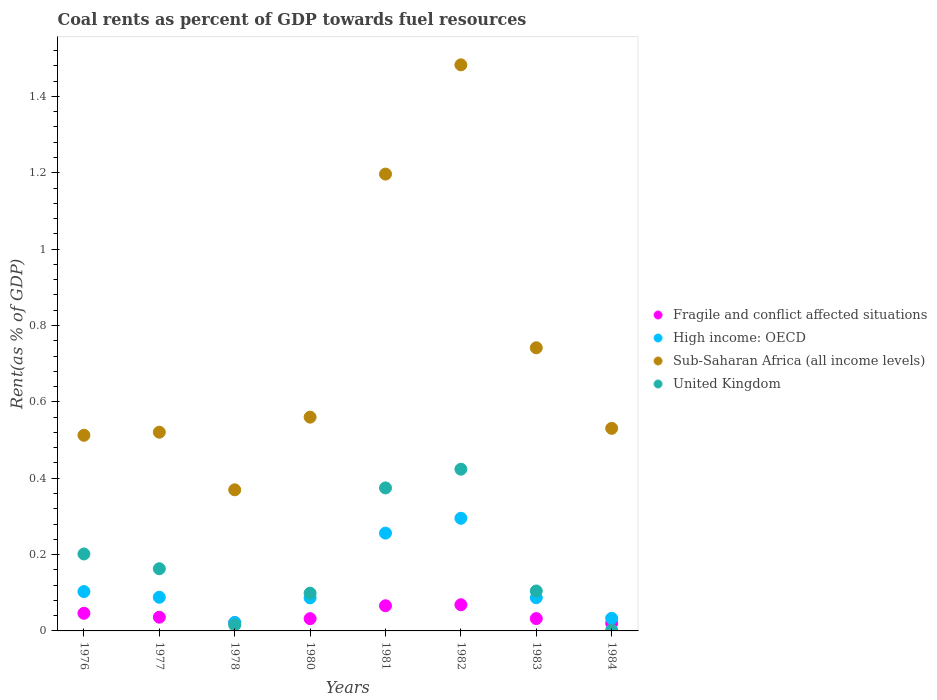How many different coloured dotlines are there?
Provide a succinct answer. 4. Is the number of dotlines equal to the number of legend labels?
Offer a very short reply. Yes. What is the coal rent in United Kingdom in 1976?
Make the answer very short. 0.2. Across all years, what is the maximum coal rent in High income: OECD?
Ensure brevity in your answer.  0.3. Across all years, what is the minimum coal rent in High income: OECD?
Give a very brief answer. 0.02. In which year was the coal rent in High income: OECD minimum?
Ensure brevity in your answer.  1978. What is the total coal rent in High income: OECD in the graph?
Make the answer very short. 0.97. What is the difference between the coal rent in United Kingdom in 1980 and that in 1981?
Keep it short and to the point. -0.28. What is the difference between the coal rent in United Kingdom in 1981 and the coal rent in High income: OECD in 1980?
Keep it short and to the point. 0.29. What is the average coal rent in High income: OECD per year?
Offer a terse response. 0.12. In the year 1981, what is the difference between the coal rent in High income: OECD and coal rent in United Kingdom?
Keep it short and to the point. -0.12. In how many years, is the coal rent in Fragile and conflict affected situations greater than 1.4800000000000002 %?
Give a very brief answer. 0. What is the ratio of the coal rent in Fragile and conflict affected situations in 1978 to that in 1984?
Your response must be concise. 1.08. Is the difference between the coal rent in High income: OECD in 1976 and 1982 greater than the difference between the coal rent in United Kingdom in 1976 and 1982?
Your answer should be very brief. Yes. What is the difference between the highest and the second highest coal rent in Fragile and conflict affected situations?
Offer a very short reply. 0. What is the difference between the highest and the lowest coal rent in United Kingdom?
Ensure brevity in your answer.  0.42. Is the coal rent in Sub-Saharan Africa (all income levels) strictly greater than the coal rent in United Kingdom over the years?
Provide a short and direct response. Yes. How many dotlines are there?
Offer a very short reply. 4. What is the difference between two consecutive major ticks on the Y-axis?
Provide a succinct answer. 0.2. Are the values on the major ticks of Y-axis written in scientific E-notation?
Your answer should be compact. No. Does the graph contain any zero values?
Offer a very short reply. No. How many legend labels are there?
Your answer should be compact. 4. How are the legend labels stacked?
Your response must be concise. Vertical. What is the title of the graph?
Offer a terse response. Coal rents as percent of GDP towards fuel resources. What is the label or title of the X-axis?
Give a very brief answer. Years. What is the label or title of the Y-axis?
Give a very brief answer. Rent(as % of GDP). What is the Rent(as % of GDP) of Fragile and conflict affected situations in 1976?
Your response must be concise. 0.05. What is the Rent(as % of GDP) of High income: OECD in 1976?
Keep it short and to the point. 0.1. What is the Rent(as % of GDP) in Sub-Saharan Africa (all income levels) in 1976?
Provide a short and direct response. 0.51. What is the Rent(as % of GDP) in United Kingdom in 1976?
Keep it short and to the point. 0.2. What is the Rent(as % of GDP) of Fragile and conflict affected situations in 1977?
Offer a terse response. 0.04. What is the Rent(as % of GDP) of High income: OECD in 1977?
Provide a succinct answer. 0.09. What is the Rent(as % of GDP) of Sub-Saharan Africa (all income levels) in 1977?
Your response must be concise. 0.52. What is the Rent(as % of GDP) of United Kingdom in 1977?
Offer a very short reply. 0.16. What is the Rent(as % of GDP) in Fragile and conflict affected situations in 1978?
Provide a short and direct response. 0.02. What is the Rent(as % of GDP) of High income: OECD in 1978?
Offer a terse response. 0.02. What is the Rent(as % of GDP) in Sub-Saharan Africa (all income levels) in 1978?
Your response must be concise. 0.37. What is the Rent(as % of GDP) in United Kingdom in 1978?
Your answer should be compact. 0.02. What is the Rent(as % of GDP) of Fragile and conflict affected situations in 1980?
Offer a very short reply. 0.03. What is the Rent(as % of GDP) in High income: OECD in 1980?
Provide a short and direct response. 0.09. What is the Rent(as % of GDP) in Sub-Saharan Africa (all income levels) in 1980?
Your response must be concise. 0.56. What is the Rent(as % of GDP) of United Kingdom in 1980?
Provide a short and direct response. 0.1. What is the Rent(as % of GDP) of Fragile and conflict affected situations in 1981?
Your response must be concise. 0.07. What is the Rent(as % of GDP) of High income: OECD in 1981?
Make the answer very short. 0.26. What is the Rent(as % of GDP) of Sub-Saharan Africa (all income levels) in 1981?
Make the answer very short. 1.2. What is the Rent(as % of GDP) in United Kingdom in 1981?
Offer a terse response. 0.37. What is the Rent(as % of GDP) in Fragile and conflict affected situations in 1982?
Offer a terse response. 0.07. What is the Rent(as % of GDP) of High income: OECD in 1982?
Give a very brief answer. 0.3. What is the Rent(as % of GDP) of Sub-Saharan Africa (all income levels) in 1982?
Provide a short and direct response. 1.48. What is the Rent(as % of GDP) of United Kingdom in 1982?
Keep it short and to the point. 0.42. What is the Rent(as % of GDP) in Fragile and conflict affected situations in 1983?
Give a very brief answer. 0.03. What is the Rent(as % of GDP) of High income: OECD in 1983?
Your answer should be compact. 0.09. What is the Rent(as % of GDP) of Sub-Saharan Africa (all income levels) in 1983?
Your answer should be compact. 0.74. What is the Rent(as % of GDP) in United Kingdom in 1983?
Your answer should be very brief. 0.1. What is the Rent(as % of GDP) of Fragile and conflict affected situations in 1984?
Your answer should be very brief. 0.02. What is the Rent(as % of GDP) in High income: OECD in 1984?
Your answer should be very brief. 0.03. What is the Rent(as % of GDP) of Sub-Saharan Africa (all income levels) in 1984?
Offer a very short reply. 0.53. What is the Rent(as % of GDP) of United Kingdom in 1984?
Your response must be concise. 0. Across all years, what is the maximum Rent(as % of GDP) of Fragile and conflict affected situations?
Your answer should be compact. 0.07. Across all years, what is the maximum Rent(as % of GDP) of High income: OECD?
Make the answer very short. 0.3. Across all years, what is the maximum Rent(as % of GDP) of Sub-Saharan Africa (all income levels)?
Your response must be concise. 1.48. Across all years, what is the maximum Rent(as % of GDP) in United Kingdom?
Provide a short and direct response. 0.42. Across all years, what is the minimum Rent(as % of GDP) in Fragile and conflict affected situations?
Offer a terse response. 0.02. Across all years, what is the minimum Rent(as % of GDP) in High income: OECD?
Keep it short and to the point. 0.02. Across all years, what is the minimum Rent(as % of GDP) in Sub-Saharan Africa (all income levels)?
Offer a terse response. 0.37. Across all years, what is the minimum Rent(as % of GDP) of United Kingdom?
Your response must be concise. 0. What is the total Rent(as % of GDP) in Fragile and conflict affected situations in the graph?
Ensure brevity in your answer.  0.32. What is the total Rent(as % of GDP) of High income: OECD in the graph?
Provide a succinct answer. 0.97. What is the total Rent(as % of GDP) of Sub-Saharan Africa (all income levels) in the graph?
Your answer should be compact. 5.91. What is the total Rent(as % of GDP) of United Kingdom in the graph?
Your answer should be compact. 1.38. What is the difference between the Rent(as % of GDP) in Fragile and conflict affected situations in 1976 and that in 1977?
Keep it short and to the point. 0.01. What is the difference between the Rent(as % of GDP) in High income: OECD in 1976 and that in 1977?
Keep it short and to the point. 0.01. What is the difference between the Rent(as % of GDP) of Sub-Saharan Africa (all income levels) in 1976 and that in 1977?
Provide a succinct answer. -0.01. What is the difference between the Rent(as % of GDP) in United Kingdom in 1976 and that in 1977?
Provide a succinct answer. 0.04. What is the difference between the Rent(as % of GDP) in Fragile and conflict affected situations in 1976 and that in 1978?
Your answer should be compact. 0.02. What is the difference between the Rent(as % of GDP) in High income: OECD in 1976 and that in 1978?
Your answer should be compact. 0.08. What is the difference between the Rent(as % of GDP) in Sub-Saharan Africa (all income levels) in 1976 and that in 1978?
Your response must be concise. 0.14. What is the difference between the Rent(as % of GDP) of United Kingdom in 1976 and that in 1978?
Ensure brevity in your answer.  0.19. What is the difference between the Rent(as % of GDP) in Fragile and conflict affected situations in 1976 and that in 1980?
Your answer should be compact. 0.01. What is the difference between the Rent(as % of GDP) in High income: OECD in 1976 and that in 1980?
Your answer should be compact. 0.02. What is the difference between the Rent(as % of GDP) of Sub-Saharan Africa (all income levels) in 1976 and that in 1980?
Provide a short and direct response. -0.05. What is the difference between the Rent(as % of GDP) in United Kingdom in 1976 and that in 1980?
Your answer should be very brief. 0.1. What is the difference between the Rent(as % of GDP) in Fragile and conflict affected situations in 1976 and that in 1981?
Give a very brief answer. -0.02. What is the difference between the Rent(as % of GDP) of High income: OECD in 1976 and that in 1981?
Provide a short and direct response. -0.15. What is the difference between the Rent(as % of GDP) of Sub-Saharan Africa (all income levels) in 1976 and that in 1981?
Provide a short and direct response. -0.68. What is the difference between the Rent(as % of GDP) of United Kingdom in 1976 and that in 1981?
Keep it short and to the point. -0.17. What is the difference between the Rent(as % of GDP) in Fragile and conflict affected situations in 1976 and that in 1982?
Your answer should be compact. -0.02. What is the difference between the Rent(as % of GDP) in High income: OECD in 1976 and that in 1982?
Offer a terse response. -0.19. What is the difference between the Rent(as % of GDP) of Sub-Saharan Africa (all income levels) in 1976 and that in 1982?
Keep it short and to the point. -0.97. What is the difference between the Rent(as % of GDP) in United Kingdom in 1976 and that in 1982?
Ensure brevity in your answer.  -0.22. What is the difference between the Rent(as % of GDP) of Fragile and conflict affected situations in 1976 and that in 1983?
Offer a very short reply. 0.01. What is the difference between the Rent(as % of GDP) in High income: OECD in 1976 and that in 1983?
Your response must be concise. 0.02. What is the difference between the Rent(as % of GDP) of Sub-Saharan Africa (all income levels) in 1976 and that in 1983?
Offer a terse response. -0.23. What is the difference between the Rent(as % of GDP) of United Kingdom in 1976 and that in 1983?
Keep it short and to the point. 0.1. What is the difference between the Rent(as % of GDP) in Fragile and conflict affected situations in 1976 and that in 1984?
Provide a short and direct response. 0.03. What is the difference between the Rent(as % of GDP) in High income: OECD in 1976 and that in 1984?
Offer a terse response. 0.07. What is the difference between the Rent(as % of GDP) in Sub-Saharan Africa (all income levels) in 1976 and that in 1984?
Provide a succinct answer. -0.02. What is the difference between the Rent(as % of GDP) in United Kingdom in 1976 and that in 1984?
Your answer should be very brief. 0.2. What is the difference between the Rent(as % of GDP) in Fragile and conflict affected situations in 1977 and that in 1978?
Your answer should be compact. 0.01. What is the difference between the Rent(as % of GDP) in High income: OECD in 1977 and that in 1978?
Your answer should be compact. 0.07. What is the difference between the Rent(as % of GDP) of Sub-Saharan Africa (all income levels) in 1977 and that in 1978?
Keep it short and to the point. 0.15. What is the difference between the Rent(as % of GDP) in United Kingdom in 1977 and that in 1978?
Ensure brevity in your answer.  0.15. What is the difference between the Rent(as % of GDP) of Fragile and conflict affected situations in 1977 and that in 1980?
Provide a short and direct response. 0. What is the difference between the Rent(as % of GDP) of High income: OECD in 1977 and that in 1980?
Ensure brevity in your answer.  0. What is the difference between the Rent(as % of GDP) of Sub-Saharan Africa (all income levels) in 1977 and that in 1980?
Offer a very short reply. -0.04. What is the difference between the Rent(as % of GDP) in United Kingdom in 1977 and that in 1980?
Ensure brevity in your answer.  0.06. What is the difference between the Rent(as % of GDP) of Fragile and conflict affected situations in 1977 and that in 1981?
Your response must be concise. -0.03. What is the difference between the Rent(as % of GDP) of High income: OECD in 1977 and that in 1981?
Your response must be concise. -0.17. What is the difference between the Rent(as % of GDP) of Sub-Saharan Africa (all income levels) in 1977 and that in 1981?
Provide a succinct answer. -0.68. What is the difference between the Rent(as % of GDP) of United Kingdom in 1977 and that in 1981?
Keep it short and to the point. -0.21. What is the difference between the Rent(as % of GDP) in Fragile and conflict affected situations in 1977 and that in 1982?
Your answer should be compact. -0.03. What is the difference between the Rent(as % of GDP) in High income: OECD in 1977 and that in 1982?
Offer a very short reply. -0.21. What is the difference between the Rent(as % of GDP) in Sub-Saharan Africa (all income levels) in 1977 and that in 1982?
Make the answer very short. -0.96. What is the difference between the Rent(as % of GDP) of United Kingdom in 1977 and that in 1982?
Your answer should be compact. -0.26. What is the difference between the Rent(as % of GDP) of Fragile and conflict affected situations in 1977 and that in 1983?
Keep it short and to the point. 0. What is the difference between the Rent(as % of GDP) in High income: OECD in 1977 and that in 1983?
Ensure brevity in your answer.  0. What is the difference between the Rent(as % of GDP) in Sub-Saharan Africa (all income levels) in 1977 and that in 1983?
Ensure brevity in your answer.  -0.22. What is the difference between the Rent(as % of GDP) of United Kingdom in 1977 and that in 1983?
Your answer should be compact. 0.06. What is the difference between the Rent(as % of GDP) in Fragile and conflict affected situations in 1977 and that in 1984?
Offer a terse response. 0.02. What is the difference between the Rent(as % of GDP) in High income: OECD in 1977 and that in 1984?
Provide a short and direct response. 0.06. What is the difference between the Rent(as % of GDP) in Sub-Saharan Africa (all income levels) in 1977 and that in 1984?
Your answer should be compact. -0.01. What is the difference between the Rent(as % of GDP) in United Kingdom in 1977 and that in 1984?
Offer a very short reply. 0.16. What is the difference between the Rent(as % of GDP) of Fragile and conflict affected situations in 1978 and that in 1980?
Your answer should be compact. -0.01. What is the difference between the Rent(as % of GDP) in High income: OECD in 1978 and that in 1980?
Provide a succinct answer. -0.06. What is the difference between the Rent(as % of GDP) of Sub-Saharan Africa (all income levels) in 1978 and that in 1980?
Your response must be concise. -0.19. What is the difference between the Rent(as % of GDP) of United Kingdom in 1978 and that in 1980?
Ensure brevity in your answer.  -0.08. What is the difference between the Rent(as % of GDP) in Fragile and conflict affected situations in 1978 and that in 1981?
Your response must be concise. -0.04. What is the difference between the Rent(as % of GDP) in High income: OECD in 1978 and that in 1981?
Make the answer very short. -0.23. What is the difference between the Rent(as % of GDP) of Sub-Saharan Africa (all income levels) in 1978 and that in 1981?
Make the answer very short. -0.83. What is the difference between the Rent(as % of GDP) of United Kingdom in 1978 and that in 1981?
Give a very brief answer. -0.36. What is the difference between the Rent(as % of GDP) of Fragile and conflict affected situations in 1978 and that in 1982?
Provide a short and direct response. -0.05. What is the difference between the Rent(as % of GDP) in High income: OECD in 1978 and that in 1982?
Provide a short and direct response. -0.27. What is the difference between the Rent(as % of GDP) of Sub-Saharan Africa (all income levels) in 1978 and that in 1982?
Make the answer very short. -1.11. What is the difference between the Rent(as % of GDP) in United Kingdom in 1978 and that in 1982?
Give a very brief answer. -0.41. What is the difference between the Rent(as % of GDP) of Fragile and conflict affected situations in 1978 and that in 1983?
Keep it short and to the point. -0.01. What is the difference between the Rent(as % of GDP) in High income: OECD in 1978 and that in 1983?
Provide a short and direct response. -0.06. What is the difference between the Rent(as % of GDP) in Sub-Saharan Africa (all income levels) in 1978 and that in 1983?
Your answer should be compact. -0.37. What is the difference between the Rent(as % of GDP) in United Kingdom in 1978 and that in 1983?
Make the answer very short. -0.09. What is the difference between the Rent(as % of GDP) in Fragile and conflict affected situations in 1978 and that in 1984?
Ensure brevity in your answer.  0. What is the difference between the Rent(as % of GDP) in High income: OECD in 1978 and that in 1984?
Your answer should be compact. -0.01. What is the difference between the Rent(as % of GDP) in Sub-Saharan Africa (all income levels) in 1978 and that in 1984?
Provide a succinct answer. -0.16. What is the difference between the Rent(as % of GDP) in United Kingdom in 1978 and that in 1984?
Your response must be concise. 0.01. What is the difference between the Rent(as % of GDP) of Fragile and conflict affected situations in 1980 and that in 1981?
Make the answer very short. -0.03. What is the difference between the Rent(as % of GDP) of High income: OECD in 1980 and that in 1981?
Ensure brevity in your answer.  -0.17. What is the difference between the Rent(as % of GDP) in Sub-Saharan Africa (all income levels) in 1980 and that in 1981?
Offer a very short reply. -0.64. What is the difference between the Rent(as % of GDP) in United Kingdom in 1980 and that in 1981?
Make the answer very short. -0.28. What is the difference between the Rent(as % of GDP) in Fragile and conflict affected situations in 1980 and that in 1982?
Give a very brief answer. -0.04. What is the difference between the Rent(as % of GDP) of High income: OECD in 1980 and that in 1982?
Make the answer very short. -0.21. What is the difference between the Rent(as % of GDP) of Sub-Saharan Africa (all income levels) in 1980 and that in 1982?
Your answer should be compact. -0.92. What is the difference between the Rent(as % of GDP) in United Kingdom in 1980 and that in 1982?
Ensure brevity in your answer.  -0.32. What is the difference between the Rent(as % of GDP) in Fragile and conflict affected situations in 1980 and that in 1983?
Offer a very short reply. -0. What is the difference between the Rent(as % of GDP) in High income: OECD in 1980 and that in 1983?
Your response must be concise. -0. What is the difference between the Rent(as % of GDP) in Sub-Saharan Africa (all income levels) in 1980 and that in 1983?
Keep it short and to the point. -0.18. What is the difference between the Rent(as % of GDP) of United Kingdom in 1980 and that in 1983?
Keep it short and to the point. -0.01. What is the difference between the Rent(as % of GDP) in Fragile and conflict affected situations in 1980 and that in 1984?
Keep it short and to the point. 0.01. What is the difference between the Rent(as % of GDP) of High income: OECD in 1980 and that in 1984?
Offer a very short reply. 0.05. What is the difference between the Rent(as % of GDP) in Sub-Saharan Africa (all income levels) in 1980 and that in 1984?
Ensure brevity in your answer.  0.03. What is the difference between the Rent(as % of GDP) of United Kingdom in 1980 and that in 1984?
Your answer should be very brief. 0.1. What is the difference between the Rent(as % of GDP) in Fragile and conflict affected situations in 1981 and that in 1982?
Your answer should be very brief. -0. What is the difference between the Rent(as % of GDP) in High income: OECD in 1981 and that in 1982?
Your answer should be compact. -0.04. What is the difference between the Rent(as % of GDP) in Sub-Saharan Africa (all income levels) in 1981 and that in 1982?
Keep it short and to the point. -0.29. What is the difference between the Rent(as % of GDP) of United Kingdom in 1981 and that in 1982?
Your answer should be very brief. -0.05. What is the difference between the Rent(as % of GDP) of Fragile and conflict affected situations in 1981 and that in 1983?
Your response must be concise. 0.03. What is the difference between the Rent(as % of GDP) of High income: OECD in 1981 and that in 1983?
Your response must be concise. 0.17. What is the difference between the Rent(as % of GDP) of Sub-Saharan Africa (all income levels) in 1981 and that in 1983?
Provide a succinct answer. 0.45. What is the difference between the Rent(as % of GDP) of United Kingdom in 1981 and that in 1983?
Make the answer very short. 0.27. What is the difference between the Rent(as % of GDP) of Fragile and conflict affected situations in 1981 and that in 1984?
Make the answer very short. 0.05. What is the difference between the Rent(as % of GDP) of High income: OECD in 1981 and that in 1984?
Your answer should be compact. 0.22. What is the difference between the Rent(as % of GDP) of Sub-Saharan Africa (all income levels) in 1981 and that in 1984?
Your answer should be very brief. 0.67. What is the difference between the Rent(as % of GDP) in United Kingdom in 1981 and that in 1984?
Ensure brevity in your answer.  0.37. What is the difference between the Rent(as % of GDP) in Fragile and conflict affected situations in 1982 and that in 1983?
Give a very brief answer. 0.04. What is the difference between the Rent(as % of GDP) of High income: OECD in 1982 and that in 1983?
Offer a very short reply. 0.21. What is the difference between the Rent(as % of GDP) of Sub-Saharan Africa (all income levels) in 1982 and that in 1983?
Offer a terse response. 0.74. What is the difference between the Rent(as % of GDP) in United Kingdom in 1982 and that in 1983?
Provide a succinct answer. 0.32. What is the difference between the Rent(as % of GDP) of Fragile and conflict affected situations in 1982 and that in 1984?
Ensure brevity in your answer.  0.05. What is the difference between the Rent(as % of GDP) of High income: OECD in 1982 and that in 1984?
Make the answer very short. 0.26. What is the difference between the Rent(as % of GDP) of Sub-Saharan Africa (all income levels) in 1982 and that in 1984?
Ensure brevity in your answer.  0.95. What is the difference between the Rent(as % of GDP) in United Kingdom in 1982 and that in 1984?
Provide a short and direct response. 0.42. What is the difference between the Rent(as % of GDP) of Fragile and conflict affected situations in 1983 and that in 1984?
Provide a short and direct response. 0.01. What is the difference between the Rent(as % of GDP) of High income: OECD in 1983 and that in 1984?
Your answer should be compact. 0.05. What is the difference between the Rent(as % of GDP) in Sub-Saharan Africa (all income levels) in 1983 and that in 1984?
Your answer should be compact. 0.21. What is the difference between the Rent(as % of GDP) of United Kingdom in 1983 and that in 1984?
Provide a succinct answer. 0.1. What is the difference between the Rent(as % of GDP) in Fragile and conflict affected situations in 1976 and the Rent(as % of GDP) in High income: OECD in 1977?
Your answer should be very brief. -0.04. What is the difference between the Rent(as % of GDP) of Fragile and conflict affected situations in 1976 and the Rent(as % of GDP) of Sub-Saharan Africa (all income levels) in 1977?
Provide a succinct answer. -0.47. What is the difference between the Rent(as % of GDP) in Fragile and conflict affected situations in 1976 and the Rent(as % of GDP) in United Kingdom in 1977?
Your response must be concise. -0.12. What is the difference between the Rent(as % of GDP) of High income: OECD in 1976 and the Rent(as % of GDP) of Sub-Saharan Africa (all income levels) in 1977?
Give a very brief answer. -0.42. What is the difference between the Rent(as % of GDP) in High income: OECD in 1976 and the Rent(as % of GDP) in United Kingdom in 1977?
Ensure brevity in your answer.  -0.06. What is the difference between the Rent(as % of GDP) in Sub-Saharan Africa (all income levels) in 1976 and the Rent(as % of GDP) in United Kingdom in 1977?
Give a very brief answer. 0.35. What is the difference between the Rent(as % of GDP) in Fragile and conflict affected situations in 1976 and the Rent(as % of GDP) in High income: OECD in 1978?
Keep it short and to the point. 0.02. What is the difference between the Rent(as % of GDP) in Fragile and conflict affected situations in 1976 and the Rent(as % of GDP) in Sub-Saharan Africa (all income levels) in 1978?
Your answer should be compact. -0.32. What is the difference between the Rent(as % of GDP) in Fragile and conflict affected situations in 1976 and the Rent(as % of GDP) in United Kingdom in 1978?
Offer a terse response. 0.03. What is the difference between the Rent(as % of GDP) in High income: OECD in 1976 and the Rent(as % of GDP) in Sub-Saharan Africa (all income levels) in 1978?
Your answer should be compact. -0.27. What is the difference between the Rent(as % of GDP) in High income: OECD in 1976 and the Rent(as % of GDP) in United Kingdom in 1978?
Your answer should be very brief. 0.09. What is the difference between the Rent(as % of GDP) in Sub-Saharan Africa (all income levels) in 1976 and the Rent(as % of GDP) in United Kingdom in 1978?
Give a very brief answer. 0.5. What is the difference between the Rent(as % of GDP) in Fragile and conflict affected situations in 1976 and the Rent(as % of GDP) in High income: OECD in 1980?
Provide a succinct answer. -0.04. What is the difference between the Rent(as % of GDP) of Fragile and conflict affected situations in 1976 and the Rent(as % of GDP) of Sub-Saharan Africa (all income levels) in 1980?
Offer a terse response. -0.51. What is the difference between the Rent(as % of GDP) in Fragile and conflict affected situations in 1976 and the Rent(as % of GDP) in United Kingdom in 1980?
Provide a succinct answer. -0.05. What is the difference between the Rent(as % of GDP) of High income: OECD in 1976 and the Rent(as % of GDP) of Sub-Saharan Africa (all income levels) in 1980?
Give a very brief answer. -0.46. What is the difference between the Rent(as % of GDP) of High income: OECD in 1976 and the Rent(as % of GDP) of United Kingdom in 1980?
Offer a terse response. 0. What is the difference between the Rent(as % of GDP) in Sub-Saharan Africa (all income levels) in 1976 and the Rent(as % of GDP) in United Kingdom in 1980?
Make the answer very short. 0.41. What is the difference between the Rent(as % of GDP) in Fragile and conflict affected situations in 1976 and the Rent(as % of GDP) in High income: OECD in 1981?
Your answer should be compact. -0.21. What is the difference between the Rent(as % of GDP) in Fragile and conflict affected situations in 1976 and the Rent(as % of GDP) in Sub-Saharan Africa (all income levels) in 1981?
Keep it short and to the point. -1.15. What is the difference between the Rent(as % of GDP) of Fragile and conflict affected situations in 1976 and the Rent(as % of GDP) of United Kingdom in 1981?
Offer a very short reply. -0.33. What is the difference between the Rent(as % of GDP) in High income: OECD in 1976 and the Rent(as % of GDP) in Sub-Saharan Africa (all income levels) in 1981?
Your answer should be very brief. -1.09. What is the difference between the Rent(as % of GDP) of High income: OECD in 1976 and the Rent(as % of GDP) of United Kingdom in 1981?
Offer a very short reply. -0.27. What is the difference between the Rent(as % of GDP) in Sub-Saharan Africa (all income levels) in 1976 and the Rent(as % of GDP) in United Kingdom in 1981?
Ensure brevity in your answer.  0.14. What is the difference between the Rent(as % of GDP) of Fragile and conflict affected situations in 1976 and the Rent(as % of GDP) of High income: OECD in 1982?
Your answer should be very brief. -0.25. What is the difference between the Rent(as % of GDP) in Fragile and conflict affected situations in 1976 and the Rent(as % of GDP) in Sub-Saharan Africa (all income levels) in 1982?
Offer a very short reply. -1.44. What is the difference between the Rent(as % of GDP) in Fragile and conflict affected situations in 1976 and the Rent(as % of GDP) in United Kingdom in 1982?
Keep it short and to the point. -0.38. What is the difference between the Rent(as % of GDP) in High income: OECD in 1976 and the Rent(as % of GDP) in Sub-Saharan Africa (all income levels) in 1982?
Offer a very short reply. -1.38. What is the difference between the Rent(as % of GDP) in High income: OECD in 1976 and the Rent(as % of GDP) in United Kingdom in 1982?
Provide a short and direct response. -0.32. What is the difference between the Rent(as % of GDP) of Sub-Saharan Africa (all income levels) in 1976 and the Rent(as % of GDP) of United Kingdom in 1982?
Offer a terse response. 0.09. What is the difference between the Rent(as % of GDP) in Fragile and conflict affected situations in 1976 and the Rent(as % of GDP) in High income: OECD in 1983?
Your response must be concise. -0.04. What is the difference between the Rent(as % of GDP) of Fragile and conflict affected situations in 1976 and the Rent(as % of GDP) of Sub-Saharan Africa (all income levels) in 1983?
Make the answer very short. -0.7. What is the difference between the Rent(as % of GDP) in Fragile and conflict affected situations in 1976 and the Rent(as % of GDP) in United Kingdom in 1983?
Keep it short and to the point. -0.06. What is the difference between the Rent(as % of GDP) of High income: OECD in 1976 and the Rent(as % of GDP) of Sub-Saharan Africa (all income levels) in 1983?
Offer a terse response. -0.64. What is the difference between the Rent(as % of GDP) of High income: OECD in 1976 and the Rent(as % of GDP) of United Kingdom in 1983?
Your answer should be very brief. -0. What is the difference between the Rent(as % of GDP) of Sub-Saharan Africa (all income levels) in 1976 and the Rent(as % of GDP) of United Kingdom in 1983?
Make the answer very short. 0.41. What is the difference between the Rent(as % of GDP) in Fragile and conflict affected situations in 1976 and the Rent(as % of GDP) in High income: OECD in 1984?
Make the answer very short. 0.01. What is the difference between the Rent(as % of GDP) in Fragile and conflict affected situations in 1976 and the Rent(as % of GDP) in Sub-Saharan Africa (all income levels) in 1984?
Your response must be concise. -0.48. What is the difference between the Rent(as % of GDP) in Fragile and conflict affected situations in 1976 and the Rent(as % of GDP) in United Kingdom in 1984?
Ensure brevity in your answer.  0.04. What is the difference between the Rent(as % of GDP) of High income: OECD in 1976 and the Rent(as % of GDP) of Sub-Saharan Africa (all income levels) in 1984?
Your answer should be very brief. -0.43. What is the difference between the Rent(as % of GDP) of High income: OECD in 1976 and the Rent(as % of GDP) of United Kingdom in 1984?
Your answer should be very brief. 0.1. What is the difference between the Rent(as % of GDP) in Sub-Saharan Africa (all income levels) in 1976 and the Rent(as % of GDP) in United Kingdom in 1984?
Your answer should be compact. 0.51. What is the difference between the Rent(as % of GDP) of Fragile and conflict affected situations in 1977 and the Rent(as % of GDP) of High income: OECD in 1978?
Your response must be concise. 0.01. What is the difference between the Rent(as % of GDP) in Fragile and conflict affected situations in 1977 and the Rent(as % of GDP) in Sub-Saharan Africa (all income levels) in 1978?
Make the answer very short. -0.33. What is the difference between the Rent(as % of GDP) in Fragile and conflict affected situations in 1977 and the Rent(as % of GDP) in United Kingdom in 1978?
Your answer should be very brief. 0.02. What is the difference between the Rent(as % of GDP) in High income: OECD in 1977 and the Rent(as % of GDP) in Sub-Saharan Africa (all income levels) in 1978?
Keep it short and to the point. -0.28. What is the difference between the Rent(as % of GDP) in High income: OECD in 1977 and the Rent(as % of GDP) in United Kingdom in 1978?
Provide a short and direct response. 0.07. What is the difference between the Rent(as % of GDP) of Sub-Saharan Africa (all income levels) in 1977 and the Rent(as % of GDP) of United Kingdom in 1978?
Provide a succinct answer. 0.51. What is the difference between the Rent(as % of GDP) of Fragile and conflict affected situations in 1977 and the Rent(as % of GDP) of High income: OECD in 1980?
Keep it short and to the point. -0.05. What is the difference between the Rent(as % of GDP) in Fragile and conflict affected situations in 1977 and the Rent(as % of GDP) in Sub-Saharan Africa (all income levels) in 1980?
Provide a succinct answer. -0.52. What is the difference between the Rent(as % of GDP) of Fragile and conflict affected situations in 1977 and the Rent(as % of GDP) of United Kingdom in 1980?
Keep it short and to the point. -0.06. What is the difference between the Rent(as % of GDP) in High income: OECD in 1977 and the Rent(as % of GDP) in Sub-Saharan Africa (all income levels) in 1980?
Give a very brief answer. -0.47. What is the difference between the Rent(as % of GDP) of High income: OECD in 1977 and the Rent(as % of GDP) of United Kingdom in 1980?
Provide a short and direct response. -0.01. What is the difference between the Rent(as % of GDP) in Sub-Saharan Africa (all income levels) in 1977 and the Rent(as % of GDP) in United Kingdom in 1980?
Make the answer very short. 0.42. What is the difference between the Rent(as % of GDP) in Fragile and conflict affected situations in 1977 and the Rent(as % of GDP) in High income: OECD in 1981?
Offer a very short reply. -0.22. What is the difference between the Rent(as % of GDP) in Fragile and conflict affected situations in 1977 and the Rent(as % of GDP) in Sub-Saharan Africa (all income levels) in 1981?
Offer a terse response. -1.16. What is the difference between the Rent(as % of GDP) of Fragile and conflict affected situations in 1977 and the Rent(as % of GDP) of United Kingdom in 1981?
Your response must be concise. -0.34. What is the difference between the Rent(as % of GDP) of High income: OECD in 1977 and the Rent(as % of GDP) of Sub-Saharan Africa (all income levels) in 1981?
Your answer should be very brief. -1.11. What is the difference between the Rent(as % of GDP) in High income: OECD in 1977 and the Rent(as % of GDP) in United Kingdom in 1981?
Offer a very short reply. -0.29. What is the difference between the Rent(as % of GDP) in Sub-Saharan Africa (all income levels) in 1977 and the Rent(as % of GDP) in United Kingdom in 1981?
Make the answer very short. 0.15. What is the difference between the Rent(as % of GDP) in Fragile and conflict affected situations in 1977 and the Rent(as % of GDP) in High income: OECD in 1982?
Your response must be concise. -0.26. What is the difference between the Rent(as % of GDP) of Fragile and conflict affected situations in 1977 and the Rent(as % of GDP) of Sub-Saharan Africa (all income levels) in 1982?
Make the answer very short. -1.45. What is the difference between the Rent(as % of GDP) of Fragile and conflict affected situations in 1977 and the Rent(as % of GDP) of United Kingdom in 1982?
Your answer should be very brief. -0.39. What is the difference between the Rent(as % of GDP) in High income: OECD in 1977 and the Rent(as % of GDP) in Sub-Saharan Africa (all income levels) in 1982?
Keep it short and to the point. -1.39. What is the difference between the Rent(as % of GDP) in High income: OECD in 1977 and the Rent(as % of GDP) in United Kingdom in 1982?
Your answer should be very brief. -0.34. What is the difference between the Rent(as % of GDP) in Sub-Saharan Africa (all income levels) in 1977 and the Rent(as % of GDP) in United Kingdom in 1982?
Offer a very short reply. 0.1. What is the difference between the Rent(as % of GDP) of Fragile and conflict affected situations in 1977 and the Rent(as % of GDP) of High income: OECD in 1983?
Make the answer very short. -0.05. What is the difference between the Rent(as % of GDP) in Fragile and conflict affected situations in 1977 and the Rent(as % of GDP) in Sub-Saharan Africa (all income levels) in 1983?
Your response must be concise. -0.71. What is the difference between the Rent(as % of GDP) of Fragile and conflict affected situations in 1977 and the Rent(as % of GDP) of United Kingdom in 1983?
Make the answer very short. -0.07. What is the difference between the Rent(as % of GDP) of High income: OECD in 1977 and the Rent(as % of GDP) of Sub-Saharan Africa (all income levels) in 1983?
Provide a succinct answer. -0.65. What is the difference between the Rent(as % of GDP) in High income: OECD in 1977 and the Rent(as % of GDP) in United Kingdom in 1983?
Your answer should be compact. -0.02. What is the difference between the Rent(as % of GDP) of Sub-Saharan Africa (all income levels) in 1977 and the Rent(as % of GDP) of United Kingdom in 1983?
Your answer should be very brief. 0.42. What is the difference between the Rent(as % of GDP) of Fragile and conflict affected situations in 1977 and the Rent(as % of GDP) of High income: OECD in 1984?
Keep it short and to the point. 0. What is the difference between the Rent(as % of GDP) of Fragile and conflict affected situations in 1977 and the Rent(as % of GDP) of Sub-Saharan Africa (all income levels) in 1984?
Keep it short and to the point. -0.49. What is the difference between the Rent(as % of GDP) in Fragile and conflict affected situations in 1977 and the Rent(as % of GDP) in United Kingdom in 1984?
Offer a terse response. 0.03. What is the difference between the Rent(as % of GDP) of High income: OECD in 1977 and the Rent(as % of GDP) of Sub-Saharan Africa (all income levels) in 1984?
Provide a short and direct response. -0.44. What is the difference between the Rent(as % of GDP) of High income: OECD in 1977 and the Rent(as % of GDP) of United Kingdom in 1984?
Offer a very short reply. 0.09. What is the difference between the Rent(as % of GDP) in Sub-Saharan Africa (all income levels) in 1977 and the Rent(as % of GDP) in United Kingdom in 1984?
Provide a short and direct response. 0.52. What is the difference between the Rent(as % of GDP) of Fragile and conflict affected situations in 1978 and the Rent(as % of GDP) of High income: OECD in 1980?
Keep it short and to the point. -0.07. What is the difference between the Rent(as % of GDP) of Fragile and conflict affected situations in 1978 and the Rent(as % of GDP) of Sub-Saharan Africa (all income levels) in 1980?
Your answer should be very brief. -0.54. What is the difference between the Rent(as % of GDP) of Fragile and conflict affected situations in 1978 and the Rent(as % of GDP) of United Kingdom in 1980?
Give a very brief answer. -0.08. What is the difference between the Rent(as % of GDP) of High income: OECD in 1978 and the Rent(as % of GDP) of Sub-Saharan Africa (all income levels) in 1980?
Ensure brevity in your answer.  -0.54. What is the difference between the Rent(as % of GDP) in High income: OECD in 1978 and the Rent(as % of GDP) in United Kingdom in 1980?
Give a very brief answer. -0.08. What is the difference between the Rent(as % of GDP) of Sub-Saharan Africa (all income levels) in 1978 and the Rent(as % of GDP) of United Kingdom in 1980?
Your answer should be compact. 0.27. What is the difference between the Rent(as % of GDP) in Fragile and conflict affected situations in 1978 and the Rent(as % of GDP) in High income: OECD in 1981?
Your response must be concise. -0.23. What is the difference between the Rent(as % of GDP) of Fragile and conflict affected situations in 1978 and the Rent(as % of GDP) of Sub-Saharan Africa (all income levels) in 1981?
Provide a succinct answer. -1.18. What is the difference between the Rent(as % of GDP) of Fragile and conflict affected situations in 1978 and the Rent(as % of GDP) of United Kingdom in 1981?
Your response must be concise. -0.35. What is the difference between the Rent(as % of GDP) in High income: OECD in 1978 and the Rent(as % of GDP) in Sub-Saharan Africa (all income levels) in 1981?
Your answer should be very brief. -1.17. What is the difference between the Rent(as % of GDP) in High income: OECD in 1978 and the Rent(as % of GDP) in United Kingdom in 1981?
Your response must be concise. -0.35. What is the difference between the Rent(as % of GDP) of Sub-Saharan Africa (all income levels) in 1978 and the Rent(as % of GDP) of United Kingdom in 1981?
Keep it short and to the point. -0.01. What is the difference between the Rent(as % of GDP) of Fragile and conflict affected situations in 1978 and the Rent(as % of GDP) of High income: OECD in 1982?
Ensure brevity in your answer.  -0.27. What is the difference between the Rent(as % of GDP) in Fragile and conflict affected situations in 1978 and the Rent(as % of GDP) in Sub-Saharan Africa (all income levels) in 1982?
Your answer should be compact. -1.46. What is the difference between the Rent(as % of GDP) in Fragile and conflict affected situations in 1978 and the Rent(as % of GDP) in United Kingdom in 1982?
Your answer should be very brief. -0.4. What is the difference between the Rent(as % of GDP) of High income: OECD in 1978 and the Rent(as % of GDP) of Sub-Saharan Africa (all income levels) in 1982?
Your answer should be very brief. -1.46. What is the difference between the Rent(as % of GDP) in High income: OECD in 1978 and the Rent(as % of GDP) in United Kingdom in 1982?
Offer a very short reply. -0.4. What is the difference between the Rent(as % of GDP) of Sub-Saharan Africa (all income levels) in 1978 and the Rent(as % of GDP) of United Kingdom in 1982?
Provide a short and direct response. -0.05. What is the difference between the Rent(as % of GDP) of Fragile and conflict affected situations in 1978 and the Rent(as % of GDP) of High income: OECD in 1983?
Provide a short and direct response. -0.07. What is the difference between the Rent(as % of GDP) in Fragile and conflict affected situations in 1978 and the Rent(as % of GDP) in Sub-Saharan Africa (all income levels) in 1983?
Make the answer very short. -0.72. What is the difference between the Rent(as % of GDP) in Fragile and conflict affected situations in 1978 and the Rent(as % of GDP) in United Kingdom in 1983?
Provide a succinct answer. -0.08. What is the difference between the Rent(as % of GDP) of High income: OECD in 1978 and the Rent(as % of GDP) of Sub-Saharan Africa (all income levels) in 1983?
Your answer should be compact. -0.72. What is the difference between the Rent(as % of GDP) of High income: OECD in 1978 and the Rent(as % of GDP) of United Kingdom in 1983?
Ensure brevity in your answer.  -0.08. What is the difference between the Rent(as % of GDP) in Sub-Saharan Africa (all income levels) in 1978 and the Rent(as % of GDP) in United Kingdom in 1983?
Provide a short and direct response. 0.27. What is the difference between the Rent(as % of GDP) of Fragile and conflict affected situations in 1978 and the Rent(as % of GDP) of High income: OECD in 1984?
Provide a succinct answer. -0.01. What is the difference between the Rent(as % of GDP) in Fragile and conflict affected situations in 1978 and the Rent(as % of GDP) in Sub-Saharan Africa (all income levels) in 1984?
Give a very brief answer. -0.51. What is the difference between the Rent(as % of GDP) in Fragile and conflict affected situations in 1978 and the Rent(as % of GDP) in United Kingdom in 1984?
Offer a terse response. 0.02. What is the difference between the Rent(as % of GDP) of High income: OECD in 1978 and the Rent(as % of GDP) of Sub-Saharan Africa (all income levels) in 1984?
Your answer should be very brief. -0.51. What is the difference between the Rent(as % of GDP) in High income: OECD in 1978 and the Rent(as % of GDP) in United Kingdom in 1984?
Offer a very short reply. 0.02. What is the difference between the Rent(as % of GDP) of Sub-Saharan Africa (all income levels) in 1978 and the Rent(as % of GDP) of United Kingdom in 1984?
Your response must be concise. 0.37. What is the difference between the Rent(as % of GDP) in Fragile and conflict affected situations in 1980 and the Rent(as % of GDP) in High income: OECD in 1981?
Offer a terse response. -0.22. What is the difference between the Rent(as % of GDP) in Fragile and conflict affected situations in 1980 and the Rent(as % of GDP) in Sub-Saharan Africa (all income levels) in 1981?
Offer a terse response. -1.16. What is the difference between the Rent(as % of GDP) in Fragile and conflict affected situations in 1980 and the Rent(as % of GDP) in United Kingdom in 1981?
Offer a very short reply. -0.34. What is the difference between the Rent(as % of GDP) in High income: OECD in 1980 and the Rent(as % of GDP) in Sub-Saharan Africa (all income levels) in 1981?
Ensure brevity in your answer.  -1.11. What is the difference between the Rent(as % of GDP) of High income: OECD in 1980 and the Rent(as % of GDP) of United Kingdom in 1981?
Your response must be concise. -0.29. What is the difference between the Rent(as % of GDP) in Sub-Saharan Africa (all income levels) in 1980 and the Rent(as % of GDP) in United Kingdom in 1981?
Provide a succinct answer. 0.19. What is the difference between the Rent(as % of GDP) of Fragile and conflict affected situations in 1980 and the Rent(as % of GDP) of High income: OECD in 1982?
Keep it short and to the point. -0.26. What is the difference between the Rent(as % of GDP) of Fragile and conflict affected situations in 1980 and the Rent(as % of GDP) of Sub-Saharan Africa (all income levels) in 1982?
Give a very brief answer. -1.45. What is the difference between the Rent(as % of GDP) in Fragile and conflict affected situations in 1980 and the Rent(as % of GDP) in United Kingdom in 1982?
Offer a terse response. -0.39. What is the difference between the Rent(as % of GDP) of High income: OECD in 1980 and the Rent(as % of GDP) of Sub-Saharan Africa (all income levels) in 1982?
Offer a very short reply. -1.4. What is the difference between the Rent(as % of GDP) of High income: OECD in 1980 and the Rent(as % of GDP) of United Kingdom in 1982?
Your answer should be compact. -0.34. What is the difference between the Rent(as % of GDP) of Sub-Saharan Africa (all income levels) in 1980 and the Rent(as % of GDP) of United Kingdom in 1982?
Provide a short and direct response. 0.14. What is the difference between the Rent(as % of GDP) of Fragile and conflict affected situations in 1980 and the Rent(as % of GDP) of High income: OECD in 1983?
Offer a very short reply. -0.05. What is the difference between the Rent(as % of GDP) in Fragile and conflict affected situations in 1980 and the Rent(as % of GDP) in Sub-Saharan Africa (all income levels) in 1983?
Give a very brief answer. -0.71. What is the difference between the Rent(as % of GDP) in Fragile and conflict affected situations in 1980 and the Rent(as % of GDP) in United Kingdom in 1983?
Offer a very short reply. -0.07. What is the difference between the Rent(as % of GDP) of High income: OECD in 1980 and the Rent(as % of GDP) of Sub-Saharan Africa (all income levels) in 1983?
Ensure brevity in your answer.  -0.66. What is the difference between the Rent(as % of GDP) of High income: OECD in 1980 and the Rent(as % of GDP) of United Kingdom in 1983?
Give a very brief answer. -0.02. What is the difference between the Rent(as % of GDP) of Sub-Saharan Africa (all income levels) in 1980 and the Rent(as % of GDP) of United Kingdom in 1983?
Your response must be concise. 0.46. What is the difference between the Rent(as % of GDP) of Fragile and conflict affected situations in 1980 and the Rent(as % of GDP) of High income: OECD in 1984?
Ensure brevity in your answer.  -0. What is the difference between the Rent(as % of GDP) of Fragile and conflict affected situations in 1980 and the Rent(as % of GDP) of Sub-Saharan Africa (all income levels) in 1984?
Ensure brevity in your answer.  -0.5. What is the difference between the Rent(as % of GDP) in Fragile and conflict affected situations in 1980 and the Rent(as % of GDP) in United Kingdom in 1984?
Keep it short and to the point. 0.03. What is the difference between the Rent(as % of GDP) in High income: OECD in 1980 and the Rent(as % of GDP) in Sub-Saharan Africa (all income levels) in 1984?
Give a very brief answer. -0.44. What is the difference between the Rent(as % of GDP) in High income: OECD in 1980 and the Rent(as % of GDP) in United Kingdom in 1984?
Your response must be concise. 0.08. What is the difference between the Rent(as % of GDP) in Sub-Saharan Africa (all income levels) in 1980 and the Rent(as % of GDP) in United Kingdom in 1984?
Offer a terse response. 0.56. What is the difference between the Rent(as % of GDP) in Fragile and conflict affected situations in 1981 and the Rent(as % of GDP) in High income: OECD in 1982?
Offer a terse response. -0.23. What is the difference between the Rent(as % of GDP) of Fragile and conflict affected situations in 1981 and the Rent(as % of GDP) of Sub-Saharan Africa (all income levels) in 1982?
Your response must be concise. -1.42. What is the difference between the Rent(as % of GDP) of Fragile and conflict affected situations in 1981 and the Rent(as % of GDP) of United Kingdom in 1982?
Your answer should be compact. -0.36. What is the difference between the Rent(as % of GDP) in High income: OECD in 1981 and the Rent(as % of GDP) in Sub-Saharan Africa (all income levels) in 1982?
Provide a short and direct response. -1.23. What is the difference between the Rent(as % of GDP) of High income: OECD in 1981 and the Rent(as % of GDP) of United Kingdom in 1982?
Your response must be concise. -0.17. What is the difference between the Rent(as % of GDP) in Sub-Saharan Africa (all income levels) in 1981 and the Rent(as % of GDP) in United Kingdom in 1982?
Give a very brief answer. 0.77. What is the difference between the Rent(as % of GDP) of Fragile and conflict affected situations in 1981 and the Rent(as % of GDP) of High income: OECD in 1983?
Keep it short and to the point. -0.02. What is the difference between the Rent(as % of GDP) in Fragile and conflict affected situations in 1981 and the Rent(as % of GDP) in Sub-Saharan Africa (all income levels) in 1983?
Provide a succinct answer. -0.68. What is the difference between the Rent(as % of GDP) in Fragile and conflict affected situations in 1981 and the Rent(as % of GDP) in United Kingdom in 1983?
Ensure brevity in your answer.  -0.04. What is the difference between the Rent(as % of GDP) in High income: OECD in 1981 and the Rent(as % of GDP) in Sub-Saharan Africa (all income levels) in 1983?
Make the answer very short. -0.49. What is the difference between the Rent(as % of GDP) of High income: OECD in 1981 and the Rent(as % of GDP) of United Kingdom in 1983?
Make the answer very short. 0.15. What is the difference between the Rent(as % of GDP) of Sub-Saharan Africa (all income levels) in 1981 and the Rent(as % of GDP) of United Kingdom in 1983?
Your answer should be very brief. 1.09. What is the difference between the Rent(as % of GDP) in Fragile and conflict affected situations in 1981 and the Rent(as % of GDP) in High income: OECD in 1984?
Your response must be concise. 0.03. What is the difference between the Rent(as % of GDP) in Fragile and conflict affected situations in 1981 and the Rent(as % of GDP) in Sub-Saharan Africa (all income levels) in 1984?
Your response must be concise. -0.46. What is the difference between the Rent(as % of GDP) in Fragile and conflict affected situations in 1981 and the Rent(as % of GDP) in United Kingdom in 1984?
Keep it short and to the point. 0.06. What is the difference between the Rent(as % of GDP) in High income: OECD in 1981 and the Rent(as % of GDP) in Sub-Saharan Africa (all income levels) in 1984?
Provide a succinct answer. -0.27. What is the difference between the Rent(as % of GDP) in High income: OECD in 1981 and the Rent(as % of GDP) in United Kingdom in 1984?
Your answer should be compact. 0.25. What is the difference between the Rent(as % of GDP) of Sub-Saharan Africa (all income levels) in 1981 and the Rent(as % of GDP) of United Kingdom in 1984?
Make the answer very short. 1.19. What is the difference between the Rent(as % of GDP) of Fragile and conflict affected situations in 1982 and the Rent(as % of GDP) of High income: OECD in 1983?
Your answer should be compact. -0.02. What is the difference between the Rent(as % of GDP) of Fragile and conflict affected situations in 1982 and the Rent(as % of GDP) of Sub-Saharan Africa (all income levels) in 1983?
Give a very brief answer. -0.67. What is the difference between the Rent(as % of GDP) of Fragile and conflict affected situations in 1982 and the Rent(as % of GDP) of United Kingdom in 1983?
Give a very brief answer. -0.04. What is the difference between the Rent(as % of GDP) in High income: OECD in 1982 and the Rent(as % of GDP) in Sub-Saharan Africa (all income levels) in 1983?
Give a very brief answer. -0.45. What is the difference between the Rent(as % of GDP) of High income: OECD in 1982 and the Rent(as % of GDP) of United Kingdom in 1983?
Your answer should be very brief. 0.19. What is the difference between the Rent(as % of GDP) of Sub-Saharan Africa (all income levels) in 1982 and the Rent(as % of GDP) of United Kingdom in 1983?
Provide a short and direct response. 1.38. What is the difference between the Rent(as % of GDP) of Fragile and conflict affected situations in 1982 and the Rent(as % of GDP) of High income: OECD in 1984?
Give a very brief answer. 0.04. What is the difference between the Rent(as % of GDP) in Fragile and conflict affected situations in 1982 and the Rent(as % of GDP) in Sub-Saharan Africa (all income levels) in 1984?
Offer a very short reply. -0.46. What is the difference between the Rent(as % of GDP) in Fragile and conflict affected situations in 1982 and the Rent(as % of GDP) in United Kingdom in 1984?
Provide a succinct answer. 0.07. What is the difference between the Rent(as % of GDP) of High income: OECD in 1982 and the Rent(as % of GDP) of Sub-Saharan Africa (all income levels) in 1984?
Your answer should be very brief. -0.24. What is the difference between the Rent(as % of GDP) in High income: OECD in 1982 and the Rent(as % of GDP) in United Kingdom in 1984?
Offer a terse response. 0.29. What is the difference between the Rent(as % of GDP) in Sub-Saharan Africa (all income levels) in 1982 and the Rent(as % of GDP) in United Kingdom in 1984?
Your response must be concise. 1.48. What is the difference between the Rent(as % of GDP) of Fragile and conflict affected situations in 1983 and the Rent(as % of GDP) of High income: OECD in 1984?
Make the answer very short. -0. What is the difference between the Rent(as % of GDP) in Fragile and conflict affected situations in 1983 and the Rent(as % of GDP) in Sub-Saharan Africa (all income levels) in 1984?
Provide a succinct answer. -0.5. What is the difference between the Rent(as % of GDP) of Fragile and conflict affected situations in 1983 and the Rent(as % of GDP) of United Kingdom in 1984?
Offer a terse response. 0.03. What is the difference between the Rent(as % of GDP) of High income: OECD in 1983 and the Rent(as % of GDP) of Sub-Saharan Africa (all income levels) in 1984?
Your response must be concise. -0.44. What is the difference between the Rent(as % of GDP) of High income: OECD in 1983 and the Rent(as % of GDP) of United Kingdom in 1984?
Ensure brevity in your answer.  0.08. What is the difference between the Rent(as % of GDP) in Sub-Saharan Africa (all income levels) in 1983 and the Rent(as % of GDP) in United Kingdom in 1984?
Keep it short and to the point. 0.74. What is the average Rent(as % of GDP) in Fragile and conflict affected situations per year?
Keep it short and to the point. 0.04. What is the average Rent(as % of GDP) of High income: OECD per year?
Ensure brevity in your answer.  0.12. What is the average Rent(as % of GDP) of Sub-Saharan Africa (all income levels) per year?
Provide a short and direct response. 0.74. What is the average Rent(as % of GDP) in United Kingdom per year?
Provide a short and direct response. 0.17. In the year 1976, what is the difference between the Rent(as % of GDP) of Fragile and conflict affected situations and Rent(as % of GDP) of High income: OECD?
Your response must be concise. -0.06. In the year 1976, what is the difference between the Rent(as % of GDP) of Fragile and conflict affected situations and Rent(as % of GDP) of Sub-Saharan Africa (all income levels)?
Ensure brevity in your answer.  -0.47. In the year 1976, what is the difference between the Rent(as % of GDP) of Fragile and conflict affected situations and Rent(as % of GDP) of United Kingdom?
Offer a very short reply. -0.16. In the year 1976, what is the difference between the Rent(as % of GDP) in High income: OECD and Rent(as % of GDP) in Sub-Saharan Africa (all income levels)?
Provide a succinct answer. -0.41. In the year 1976, what is the difference between the Rent(as % of GDP) of High income: OECD and Rent(as % of GDP) of United Kingdom?
Offer a very short reply. -0.1. In the year 1976, what is the difference between the Rent(as % of GDP) of Sub-Saharan Africa (all income levels) and Rent(as % of GDP) of United Kingdom?
Your response must be concise. 0.31. In the year 1977, what is the difference between the Rent(as % of GDP) in Fragile and conflict affected situations and Rent(as % of GDP) in High income: OECD?
Provide a short and direct response. -0.05. In the year 1977, what is the difference between the Rent(as % of GDP) in Fragile and conflict affected situations and Rent(as % of GDP) in Sub-Saharan Africa (all income levels)?
Give a very brief answer. -0.48. In the year 1977, what is the difference between the Rent(as % of GDP) in Fragile and conflict affected situations and Rent(as % of GDP) in United Kingdom?
Provide a short and direct response. -0.13. In the year 1977, what is the difference between the Rent(as % of GDP) of High income: OECD and Rent(as % of GDP) of Sub-Saharan Africa (all income levels)?
Offer a terse response. -0.43. In the year 1977, what is the difference between the Rent(as % of GDP) of High income: OECD and Rent(as % of GDP) of United Kingdom?
Your answer should be very brief. -0.07. In the year 1977, what is the difference between the Rent(as % of GDP) in Sub-Saharan Africa (all income levels) and Rent(as % of GDP) in United Kingdom?
Your response must be concise. 0.36. In the year 1978, what is the difference between the Rent(as % of GDP) of Fragile and conflict affected situations and Rent(as % of GDP) of High income: OECD?
Your response must be concise. -0. In the year 1978, what is the difference between the Rent(as % of GDP) of Fragile and conflict affected situations and Rent(as % of GDP) of Sub-Saharan Africa (all income levels)?
Your answer should be compact. -0.35. In the year 1978, what is the difference between the Rent(as % of GDP) in Fragile and conflict affected situations and Rent(as % of GDP) in United Kingdom?
Keep it short and to the point. 0.01. In the year 1978, what is the difference between the Rent(as % of GDP) in High income: OECD and Rent(as % of GDP) in Sub-Saharan Africa (all income levels)?
Give a very brief answer. -0.35. In the year 1978, what is the difference between the Rent(as % of GDP) in High income: OECD and Rent(as % of GDP) in United Kingdom?
Your answer should be very brief. 0.01. In the year 1978, what is the difference between the Rent(as % of GDP) in Sub-Saharan Africa (all income levels) and Rent(as % of GDP) in United Kingdom?
Provide a short and direct response. 0.35. In the year 1980, what is the difference between the Rent(as % of GDP) of Fragile and conflict affected situations and Rent(as % of GDP) of High income: OECD?
Ensure brevity in your answer.  -0.05. In the year 1980, what is the difference between the Rent(as % of GDP) in Fragile and conflict affected situations and Rent(as % of GDP) in Sub-Saharan Africa (all income levels)?
Your answer should be very brief. -0.53. In the year 1980, what is the difference between the Rent(as % of GDP) in Fragile and conflict affected situations and Rent(as % of GDP) in United Kingdom?
Ensure brevity in your answer.  -0.07. In the year 1980, what is the difference between the Rent(as % of GDP) of High income: OECD and Rent(as % of GDP) of Sub-Saharan Africa (all income levels)?
Provide a short and direct response. -0.47. In the year 1980, what is the difference between the Rent(as % of GDP) in High income: OECD and Rent(as % of GDP) in United Kingdom?
Provide a succinct answer. -0.01. In the year 1980, what is the difference between the Rent(as % of GDP) in Sub-Saharan Africa (all income levels) and Rent(as % of GDP) in United Kingdom?
Provide a short and direct response. 0.46. In the year 1981, what is the difference between the Rent(as % of GDP) in Fragile and conflict affected situations and Rent(as % of GDP) in High income: OECD?
Ensure brevity in your answer.  -0.19. In the year 1981, what is the difference between the Rent(as % of GDP) in Fragile and conflict affected situations and Rent(as % of GDP) in Sub-Saharan Africa (all income levels)?
Your answer should be very brief. -1.13. In the year 1981, what is the difference between the Rent(as % of GDP) in Fragile and conflict affected situations and Rent(as % of GDP) in United Kingdom?
Give a very brief answer. -0.31. In the year 1981, what is the difference between the Rent(as % of GDP) in High income: OECD and Rent(as % of GDP) in Sub-Saharan Africa (all income levels)?
Your answer should be very brief. -0.94. In the year 1981, what is the difference between the Rent(as % of GDP) in High income: OECD and Rent(as % of GDP) in United Kingdom?
Your answer should be very brief. -0.12. In the year 1981, what is the difference between the Rent(as % of GDP) in Sub-Saharan Africa (all income levels) and Rent(as % of GDP) in United Kingdom?
Offer a terse response. 0.82. In the year 1982, what is the difference between the Rent(as % of GDP) of Fragile and conflict affected situations and Rent(as % of GDP) of High income: OECD?
Your response must be concise. -0.23. In the year 1982, what is the difference between the Rent(as % of GDP) of Fragile and conflict affected situations and Rent(as % of GDP) of Sub-Saharan Africa (all income levels)?
Your answer should be compact. -1.41. In the year 1982, what is the difference between the Rent(as % of GDP) of Fragile and conflict affected situations and Rent(as % of GDP) of United Kingdom?
Keep it short and to the point. -0.35. In the year 1982, what is the difference between the Rent(as % of GDP) of High income: OECD and Rent(as % of GDP) of Sub-Saharan Africa (all income levels)?
Provide a succinct answer. -1.19. In the year 1982, what is the difference between the Rent(as % of GDP) in High income: OECD and Rent(as % of GDP) in United Kingdom?
Give a very brief answer. -0.13. In the year 1982, what is the difference between the Rent(as % of GDP) in Sub-Saharan Africa (all income levels) and Rent(as % of GDP) in United Kingdom?
Keep it short and to the point. 1.06. In the year 1983, what is the difference between the Rent(as % of GDP) of Fragile and conflict affected situations and Rent(as % of GDP) of High income: OECD?
Provide a succinct answer. -0.05. In the year 1983, what is the difference between the Rent(as % of GDP) in Fragile and conflict affected situations and Rent(as % of GDP) in Sub-Saharan Africa (all income levels)?
Provide a short and direct response. -0.71. In the year 1983, what is the difference between the Rent(as % of GDP) of Fragile and conflict affected situations and Rent(as % of GDP) of United Kingdom?
Give a very brief answer. -0.07. In the year 1983, what is the difference between the Rent(as % of GDP) in High income: OECD and Rent(as % of GDP) in Sub-Saharan Africa (all income levels)?
Provide a succinct answer. -0.65. In the year 1983, what is the difference between the Rent(as % of GDP) in High income: OECD and Rent(as % of GDP) in United Kingdom?
Offer a terse response. -0.02. In the year 1983, what is the difference between the Rent(as % of GDP) in Sub-Saharan Africa (all income levels) and Rent(as % of GDP) in United Kingdom?
Give a very brief answer. 0.64. In the year 1984, what is the difference between the Rent(as % of GDP) of Fragile and conflict affected situations and Rent(as % of GDP) of High income: OECD?
Make the answer very short. -0.01. In the year 1984, what is the difference between the Rent(as % of GDP) in Fragile and conflict affected situations and Rent(as % of GDP) in Sub-Saharan Africa (all income levels)?
Offer a very short reply. -0.51. In the year 1984, what is the difference between the Rent(as % of GDP) in Fragile and conflict affected situations and Rent(as % of GDP) in United Kingdom?
Make the answer very short. 0.02. In the year 1984, what is the difference between the Rent(as % of GDP) in High income: OECD and Rent(as % of GDP) in Sub-Saharan Africa (all income levels)?
Keep it short and to the point. -0.5. In the year 1984, what is the difference between the Rent(as % of GDP) in High income: OECD and Rent(as % of GDP) in United Kingdom?
Offer a terse response. 0.03. In the year 1984, what is the difference between the Rent(as % of GDP) in Sub-Saharan Africa (all income levels) and Rent(as % of GDP) in United Kingdom?
Keep it short and to the point. 0.53. What is the ratio of the Rent(as % of GDP) of Fragile and conflict affected situations in 1976 to that in 1977?
Your response must be concise. 1.29. What is the ratio of the Rent(as % of GDP) of High income: OECD in 1976 to that in 1977?
Make the answer very short. 1.17. What is the ratio of the Rent(as % of GDP) in Sub-Saharan Africa (all income levels) in 1976 to that in 1977?
Provide a short and direct response. 0.98. What is the ratio of the Rent(as % of GDP) of United Kingdom in 1976 to that in 1977?
Keep it short and to the point. 1.24. What is the ratio of the Rent(as % of GDP) of Fragile and conflict affected situations in 1976 to that in 1978?
Give a very brief answer. 2.15. What is the ratio of the Rent(as % of GDP) in High income: OECD in 1976 to that in 1978?
Offer a terse response. 4.65. What is the ratio of the Rent(as % of GDP) of Sub-Saharan Africa (all income levels) in 1976 to that in 1978?
Give a very brief answer. 1.39. What is the ratio of the Rent(as % of GDP) of United Kingdom in 1976 to that in 1978?
Keep it short and to the point. 13.04. What is the ratio of the Rent(as % of GDP) in Fragile and conflict affected situations in 1976 to that in 1980?
Your answer should be very brief. 1.44. What is the ratio of the Rent(as % of GDP) in High income: OECD in 1976 to that in 1980?
Give a very brief answer. 1.19. What is the ratio of the Rent(as % of GDP) in Sub-Saharan Africa (all income levels) in 1976 to that in 1980?
Your answer should be compact. 0.92. What is the ratio of the Rent(as % of GDP) of United Kingdom in 1976 to that in 1980?
Your answer should be very brief. 2.04. What is the ratio of the Rent(as % of GDP) in Fragile and conflict affected situations in 1976 to that in 1981?
Your answer should be very brief. 0.7. What is the ratio of the Rent(as % of GDP) in High income: OECD in 1976 to that in 1981?
Make the answer very short. 0.4. What is the ratio of the Rent(as % of GDP) of Sub-Saharan Africa (all income levels) in 1976 to that in 1981?
Offer a terse response. 0.43. What is the ratio of the Rent(as % of GDP) in United Kingdom in 1976 to that in 1981?
Make the answer very short. 0.54. What is the ratio of the Rent(as % of GDP) in Fragile and conflict affected situations in 1976 to that in 1982?
Your response must be concise. 0.67. What is the ratio of the Rent(as % of GDP) in High income: OECD in 1976 to that in 1982?
Ensure brevity in your answer.  0.35. What is the ratio of the Rent(as % of GDP) of Sub-Saharan Africa (all income levels) in 1976 to that in 1982?
Your answer should be compact. 0.35. What is the ratio of the Rent(as % of GDP) in United Kingdom in 1976 to that in 1982?
Offer a very short reply. 0.48. What is the ratio of the Rent(as % of GDP) in Fragile and conflict affected situations in 1976 to that in 1983?
Provide a succinct answer. 1.43. What is the ratio of the Rent(as % of GDP) in High income: OECD in 1976 to that in 1983?
Provide a short and direct response. 1.18. What is the ratio of the Rent(as % of GDP) of Sub-Saharan Africa (all income levels) in 1976 to that in 1983?
Your answer should be very brief. 0.69. What is the ratio of the Rent(as % of GDP) of United Kingdom in 1976 to that in 1983?
Offer a very short reply. 1.93. What is the ratio of the Rent(as % of GDP) of Fragile and conflict affected situations in 1976 to that in 1984?
Provide a succinct answer. 2.32. What is the ratio of the Rent(as % of GDP) of High income: OECD in 1976 to that in 1984?
Provide a short and direct response. 3.12. What is the ratio of the Rent(as % of GDP) in Sub-Saharan Africa (all income levels) in 1976 to that in 1984?
Keep it short and to the point. 0.97. What is the ratio of the Rent(as % of GDP) of United Kingdom in 1976 to that in 1984?
Provide a short and direct response. 94.8. What is the ratio of the Rent(as % of GDP) in Fragile and conflict affected situations in 1977 to that in 1978?
Provide a succinct answer. 1.67. What is the ratio of the Rent(as % of GDP) of High income: OECD in 1977 to that in 1978?
Your response must be concise. 3.97. What is the ratio of the Rent(as % of GDP) in Sub-Saharan Africa (all income levels) in 1977 to that in 1978?
Give a very brief answer. 1.41. What is the ratio of the Rent(as % of GDP) in United Kingdom in 1977 to that in 1978?
Provide a short and direct response. 10.54. What is the ratio of the Rent(as % of GDP) in Fragile and conflict affected situations in 1977 to that in 1980?
Provide a succinct answer. 1.12. What is the ratio of the Rent(as % of GDP) in High income: OECD in 1977 to that in 1980?
Make the answer very short. 1.02. What is the ratio of the Rent(as % of GDP) in Sub-Saharan Africa (all income levels) in 1977 to that in 1980?
Ensure brevity in your answer.  0.93. What is the ratio of the Rent(as % of GDP) in United Kingdom in 1977 to that in 1980?
Give a very brief answer. 1.65. What is the ratio of the Rent(as % of GDP) in Fragile and conflict affected situations in 1977 to that in 1981?
Provide a short and direct response. 0.54. What is the ratio of the Rent(as % of GDP) of High income: OECD in 1977 to that in 1981?
Offer a terse response. 0.34. What is the ratio of the Rent(as % of GDP) of Sub-Saharan Africa (all income levels) in 1977 to that in 1981?
Your answer should be compact. 0.43. What is the ratio of the Rent(as % of GDP) of United Kingdom in 1977 to that in 1981?
Your answer should be very brief. 0.43. What is the ratio of the Rent(as % of GDP) of Fragile and conflict affected situations in 1977 to that in 1982?
Offer a terse response. 0.52. What is the ratio of the Rent(as % of GDP) of High income: OECD in 1977 to that in 1982?
Make the answer very short. 0.3. What is the ratio of the Rent(as % of GDP) in Sub-Saharan Africa (all income levels) in 1977 to that in 1982?
Ensure brevity in your answer.  0.35. What is the ratio of the Rent(as % of GDP) of United Kingdom in 1977 to that in 1982?
Give a very brief answer. 0.38. What is the ratio of the Rent(as % of GDP) of Fragile and conflict affected situations in 1977 to that in 1983?
Offer a very short reply. 1.11. What is the ratio of the Rent(as % of GDP) in High income: OECD in 1977 to that in 1983?
Your answer should be compact. 1.01. What is the ratio of the Rent(as % of GDP) of Sub-Saharan Africa (all income levels) in 1977 to that in 1983?
Keep it short and to the point. 0.7. What is the ratio of the Rent(as % of GDP) of United Kingdom in 1977 to that in 1983?
Provide a succinct answer. 1.56. What is the ratio of the Rent(as % of GDP) of Fragile and conflict affected situations in 1977 to that in 1984?
Give a very brief answer. 1.8. What is the ratio of the Rent(as % of GDP) of High income: OECD in 1977 to that in 1984?
Make the answer very short. 2.67. What is the ratio of the Rent(as % of GDP) of Sub-Saharan Africa (all income levels) in 1977 to that in 1984?
Provide a short and direct response. 0.98. What is the ratio of the Rent(as % of GDP) in United Kingdom in 1977 to that in 1984?
Give a very brief answer. 76.61. What is the ratio of the Rent(as % of GDP) of Fragile and conflict affected situations in 1978 to that in 1980?
Your answer should be compact. 0.67. What is the ratio of the Rent(as % of GDP) in High income: OECD in 1978 to that in 1980?
Offer a terse response. 0.26. What is the ratio of the Rent(as % of GDP) in Sub-Saharan Africa (all income levels) in 1978 to that in 1980?
Keep it short and to the point. 0.66. What is the ratio of the Rent(as % of GDP) in United Kingdom in 1978 to that in 1980?
Your answer should be very brief. 0.16. What is the ratio of the Rent(as % of GDP) of Fragile and conflict affected situations in 1978 to that in 1981?
Provide a succinct answer. 0.33. What is the ratio of the Rent(as % of GDP) of High income: OECD in 1978 to that in 1981?
Offer a very short reply. 0.09. What is the ratio of the Rent(as % of GDP) in Sub-Saharan Africa (all income levels) in 1978 to that in 1981?
Make the answer very short. 0.31. What is the ratio of the Rent(as % of GDP) in United Kingdom in 1978 to that in 1981?
Ensure brevity in your answer.  0.04. What is the ratio of the Rent(as % of GDP) of Fragile and conflict affected situations in 1978 to that in 1982?
Your response must be concise. 0.31. What is the ratio of the Rent(as % of GDP) of High income: OECD in 1978 to that in 1982?
Your answer should be compact. 0.08. What is the ratio of the Rent(as % of GDP) in Sub-Saharan Africa (all income levels) in 1978 to that in 1982?
Offer a terse response. 0.25. What is the ratio of the Rent(as % of GDP) in United Kingdom in 1978 to that in 1982?
Give a very brief answer. 0.04. What is the ratio of the Rent(as % of GDP) in Fragile and conflict affected situations in 1978 to that in 1983?
Offer a terse response. 0.66. What is the ratio of the Rent(as % of GDP) in High income: OECD in 1978 to that in 1983?
Provide a short and direct response. 0.25. What is the ratio of the Rent(as % of GDP) in Sub-Saharan Africa (all income levels) in 1978 to that in 1983?
Offer a very short reply. 0.5. What is the ratio of the Rent(as % of GDP) in United Kingdom in 1978 to that in 1983?
Keep it short and to the point. 0.15. What is the ratio of the Rent(as % of GDP) of Fragile and conflict affected situations in 1978 to that in 1984?
Your answer should be compact. 1.08. What is the ratio of the Rent(as % of GDP) in High income: OECD in 1978 to that in 1984?
Your answer should be very brief. 0.67. What is the ratio of the Rent(as % of GDP) in Sub-Saharan Africa (all income levels) in 1978 to that in 1984?
Ensure brevity in your answer.  0.7. What is the ratio of the Rent(as % of GDP) of United Kingdom in 1978 to that in 1984?
Make the answer very short. 7.27. What is the ratio of the Rent(as % of GDP) in Fragile and conflict affected situations in 1980 to that in 1981?
Provide a succinct answer. 0.49. What is the ratio of the Rent(as % of GDP) of High income: OECD in 1980 to that in 1981?
Provide a short and direct response. 0.34. What is the ratio of the Rent(as % of GDP) in Sub-Saharan Africa (all income levels) in 1980 to that in 1981?
Offer a terse response. 0.47. What is the ratio of the Rent(as % of GDP) of United Kingdom in 1980 to that in 1981?
Your answer should be compact. 0.26. What is the ratio of the Rent(as % of GDP) of Fragile and conflict affected situations in 1980 to that in 1982?
Provide a succinct answer. 0.47. What is the ratio of the Rent(as % of GDP) of High income: OECD in 1980 to that in 1982?
Offer a terse response. 0.29. What is the ratio of the Rent(as % of GDP) in Sub-Saharan Africa (all income levels) in 1980 to that in 1982?
Your answer should be compact. 0.38. What is the ratio of the Rent(as % of GDP) in United Kingdom in 1980 to that in 1982?
Offer a terse response. 0.23. What is the ratio of the Rent(as % of GDP) in Fragile and conflict affected situations in 1980 to that in 1983?
Keep it short and to the point. 0.99. What is the ratio of the Rent(as % of GDP) of High income: OECD in 1980 to that in 1983?
Ensure brevity in your answer.  0.99. What is the ratio of the Rent(as % of GDP) of Sub-Saharan Africa (all income levels) in 1980 to that in 1983?
Provide a short and direct response. 0.76. What is the ratio of the Rent(as % of GDP) in United Kingdom in 1980 to that in 1983?
Your answer should be compact. 0.94. What is the ratio of the Rent(as % of GDP) in Fragile and conflict affected situations in 1980 to that in 1984?
Your response must be concise. 1.61. What is the ratio of the Rent(as % of GDP) of High income: OECD in 1980 to that in 1984?
Keep it short and to the point. 2.62. What is the ratio of the Rent(as % of GDP) in Sub-Saharan Africa (all income levels) in 1980 to that in 1984?
Your answer should be compact. 1.06. What is the ratio of the Rent(as % of GDP) in United Kingdom in 1980 to that in 1984?
Keep it short and to the point. 46.5. What is the ratio of the Rent(as % of GDP) of Fragile and conflict affected situations in 1981 to that in 1982?
Your response must be concise. 0.96. What is the ratio of the Rent(as % of GDP) of High income: OECD in 1981 to that in 1982?
Offer a very short reply. 0.87. What is the ratio of the Rent(as % of GDP) of Sub-Saharan Africa (all income levels) in 1981 to that in 1982?
Ensure brevity in your answer.  0.81. What is the ratio of the Rent(as % of GDP) in United Kingdom in 1981 to that in 1982?
Ensure brevity in your answer.  0.88. What is the ratio of the Rent(as % of GDP) in Fragile and conflict affected situations in 1981 to that in 1983?
Provide a succinct answer. 2.04. What is the ratio of the Rent(as % of GDP) of High income: OECD in 1981 to that in 1983?
Your response must be concise. 2.94. What is the ratio of the Rent(as % of GDP) in Sub-Saharan Africa (all income levels) in 1981 to that in 1983?
Give a very brief answer. 1.61. What is the ratio of the Rent(as % of GDP) in United Kingdom in 1981 to that in 1983?
Offer a very short reply. 3.58. What is the ratio of the Rent(as % of GDP) of Fragile and conflict affected situations in 1981 to that in 1984?
Keep it short and to the point. 3.31. What is the ratio of the Rent(as % of GDP) of High income: OECD in 1981 to that in 1984?
Provide a succinct answer. 7.75. What is the ratio of the Rent(as % of GDP) of Sub-Saharan Africa (all income levels) in 1981 to that in 1984?
Make the answer very short. 2.26. What is the ratio of the Rent(as % of GDP) in United Kingdom in 1981 to that in 1984?
Offer a very short reply. 176.18. What is the ratio of the Rent(as % of GDP) in Fragile and conflict affected situations in 1982 to that in 1983?
Give a very brief answer. 2.12. What is the ratio of the Rent(as % of GDP) of High income: OECD in 1982 to that in 1983?
Offer a terse response. 3.39. What is the ratio of the Rent(as % of GDP) of Sub-Saharan Africa (all income levels) in 1982 to that in 1983?
Ensure brevity in your answer.  2. What is the ratio of the Rent(as % of GDP) in United Kingdom in 1982 to that in 1983?
Ensure brevity in your answer.  4.05. What is the ratio of the Rent(as % of GDP) of Fragile and conflict affected situations in 1982 to that in 1984?
Offer a terse response. 3.44. What is the ratio of the Rent(as % of GDP) in High income: OECD in 1982 to that in 1984?
Offer a very short reply. 8.93. What is the ratio of the Rent(as % of GDP) of Sub-Saharan Africa (all income levels) in 1982 to that in 1984?
Your response must be concise. 2.79. What is the ratio of the Rent(as % of GDP) of United Kingdom in 1982 to that in 1984?
Give a very brief answer. 199.24. What is the ratio of the Rent(as % of GDP) of Fragile and conflict affected situations in 1983 to that in 1984?
Offer a very short reply. 1.62. What is the ratio of the Rent(as % of GDP) of High income: OECD in 1983 to that in 1984?
Ensure brevity in your answer.  2.63. What is the ratio of the Rent(as % of GDP) in Sub-Saharan Africa (all income levels) in 1983 to that in 1984?
Provide a short and direct response. 1.4. What is the ratio of the Rent(as % of GDP) in United Kingdom in 1983 to that in 1984?
Your answer should be compact. 49.21. What is the difference between the highest and the second highest Rent(as % of GDP) of Fragile and conflict affected situations?
Provide a succinct answer. 0. What is the difference between the highest and the second highest Rent(as % of GDP) of High income: OECD?
Provide a succinct answer. 0.04. What is the difference between the highest and the second highest Rent(as % of GDP) of Sub-Saharan Africa (all income levels)?
Give a very brief answer. 0.29. What is the difference between the highest and the second highest Rent(as % of GDP) in United Kingdom?
Ensure brevity in your answer.  0.05. What is the difference between the highest and the lowest Rent(as % of GDP) of Fragile and conflict affected situations?
Offer a very short reply. 0.05. What is the difference between the highest and the lowest Rent(as % of GDP) of High income: OECD?
Keep it short and to the point. 0.27. What is the difference between the highest and the lowest Rent(as % of GDP) of Sub-Saharan Africa (all income levels)?
Provide a short and direct response. 1.11. What is the difference between the highest and the lowest Rent(as % of GDP) of United Kingdom?
Your answer should be compact. 0.42. 